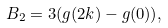<formula> <loc_0><loc_0><loc_500><loc_500>B _ { 2 } = 3 ( g ( 2 k ) - g ( 0 ) ) ,</formula> 